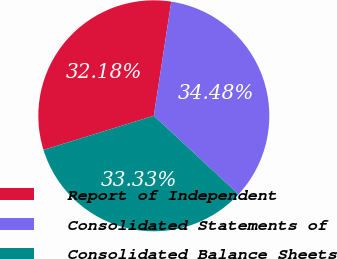<chart> <loc_0><loc_0><loc_500><loc_500><pie_chart><fcel>Report of Independent<fcel>Consolidated Statements of<fcel>Consolidated Balance Sheets<nl><fcel>32.18%<fcel>34.48%<fcel>33.33%<nl></chart> 